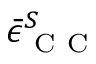<formula> <loc_0><loc_0><loc_500><loc_500>\bar { \epsilon } _ { C C } ^ { S }</formula> 